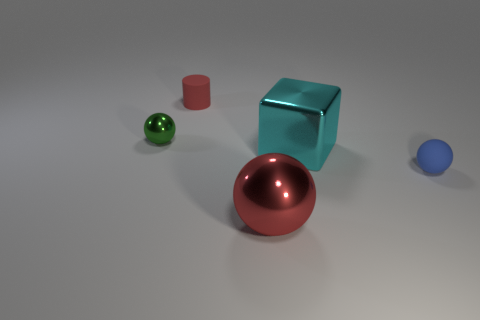Subtract all small metal spheres. How many spheres are left? 2 Add 4 small green matte balls. How many objects exist? 9 Subtract all green spheres. How many spheres are left? 2 Subtract 2 spheres. How many spheres are left? 1 Subtract all spheres. How many objects are left? 2 Subtract all brown cubes. Subtract all green cylinders. How many cubes are left? 1 Subtract all green cylinders. How many green spheres are left? 1 Subtract all rubber things. Subtract all matte cylinders. How many objects are left? 2 Add 4 tiny red objects. How many tiny red objects are left? 5 Add 3 large yellow things. How many large yellow things exist? 3 